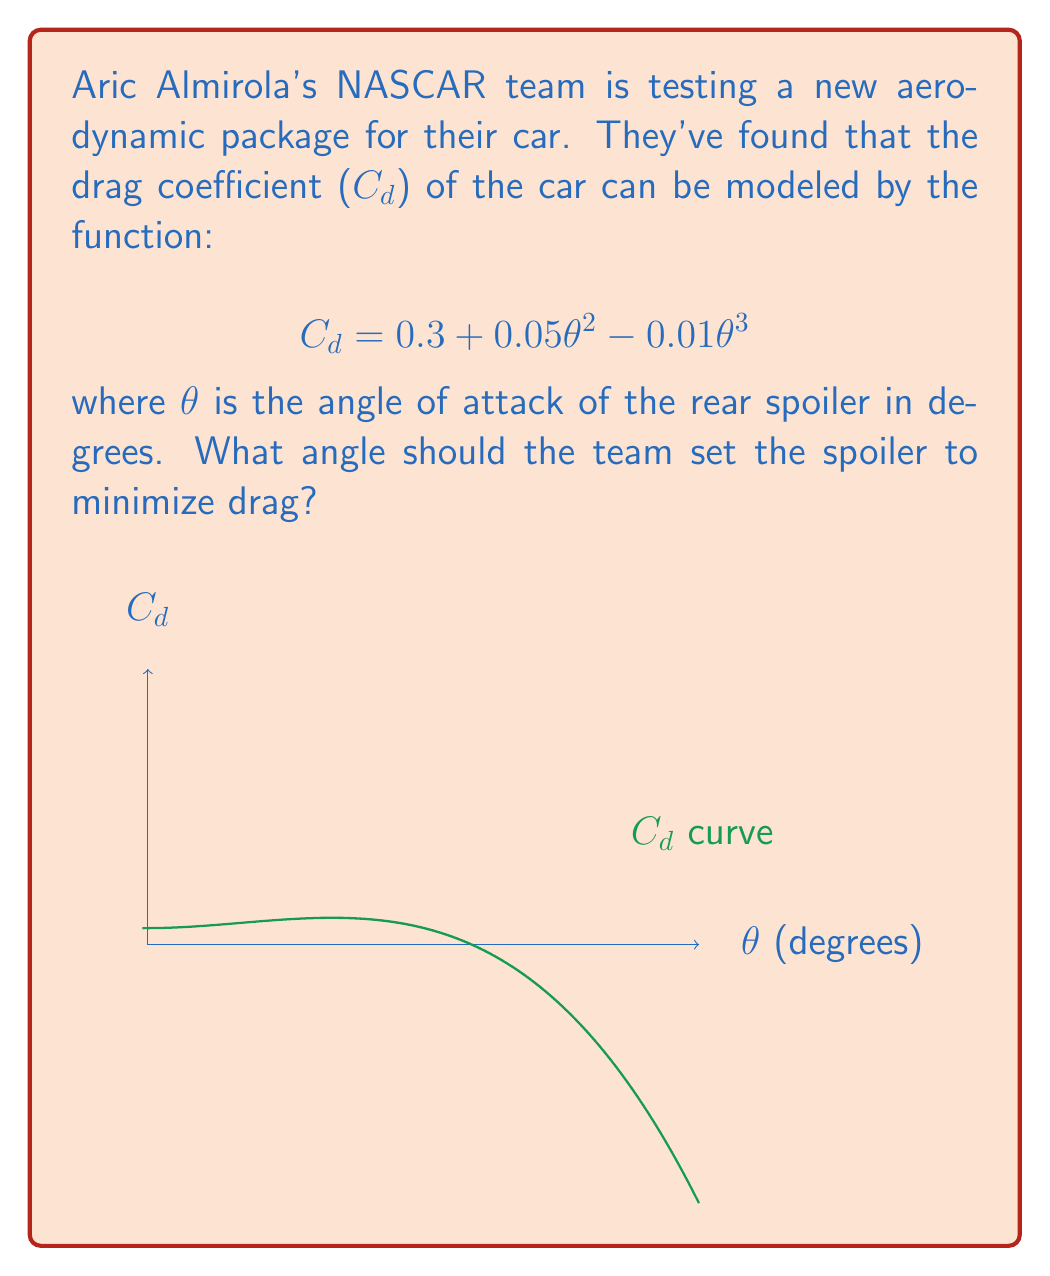Can you answer this question? To find the angle that minimizes drag, we need to find the minimum of the $C_d$ function. This occurs where the derivative of $C_d$ with respect to $\theta$ is zero.

1) First, let's find the derivative of $C_d$:
   $$\frac{dC_d}{d\theta} = 0.1\theta - 0.03\theta^2$$

2) Set this equal to zero and solve:
   $$0.1\theta - 0.03\theta^2 = 0$$
   $$\theta(0.1 - 0.03\theta) = 0$$

3) This equation is satisfied when $\theta = 0$ or when $0.1 - 0.03\theta = 0$

4) Solving $0.1 - 0.03\theta = 0$:
   $$0.03\theta = 0.1$$
   $$\theta = \frac{0.1}{0.03} \approx 3.33$$

5) To confirm this is a minimum (not a maximum), we can check the second derivative:
   $$\frac{d^2C_d}{d\theta^2} = 0.1 - 0.06\theta$$
   At $\theta = 3.33$, this is positive, confirming a minimum.

6) Therefore, the drag is minimized when $\theta \approx 3.33$ degrees.
Answer: 3.33 degrees 